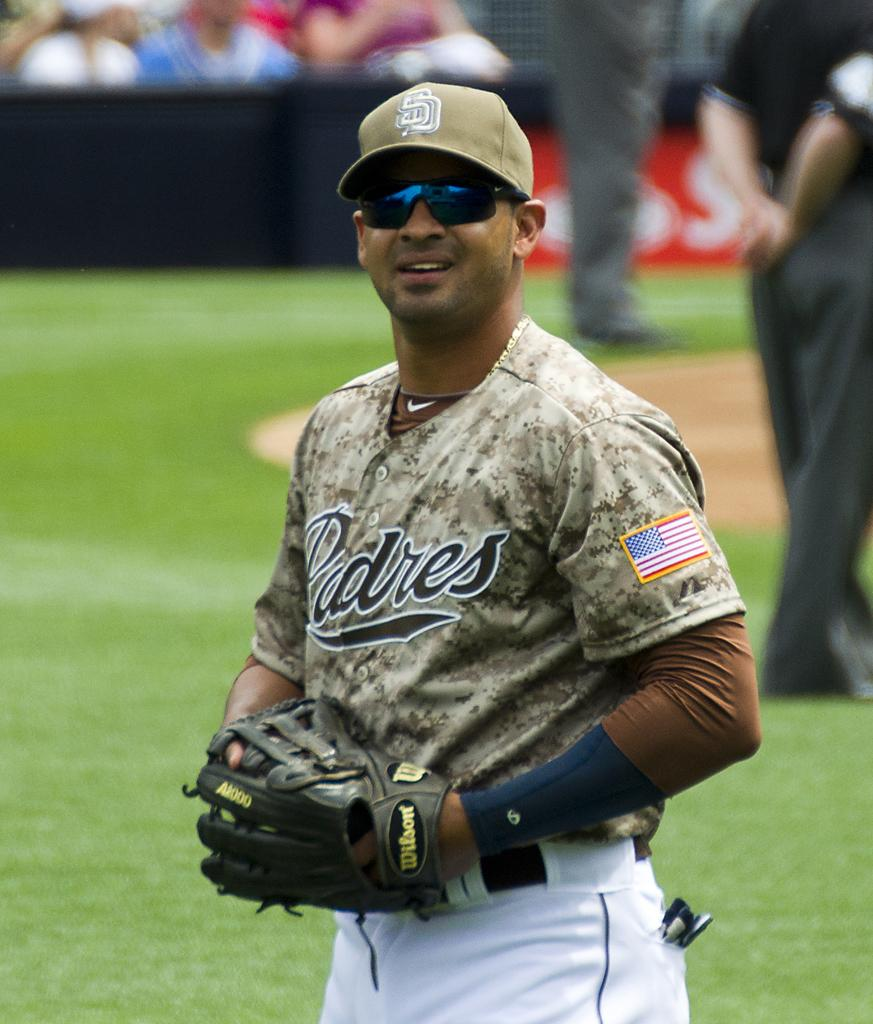Provide a one-sentence caption for the provided image. The pitcher for the Padres with sunglasses and in a camo jersey. 